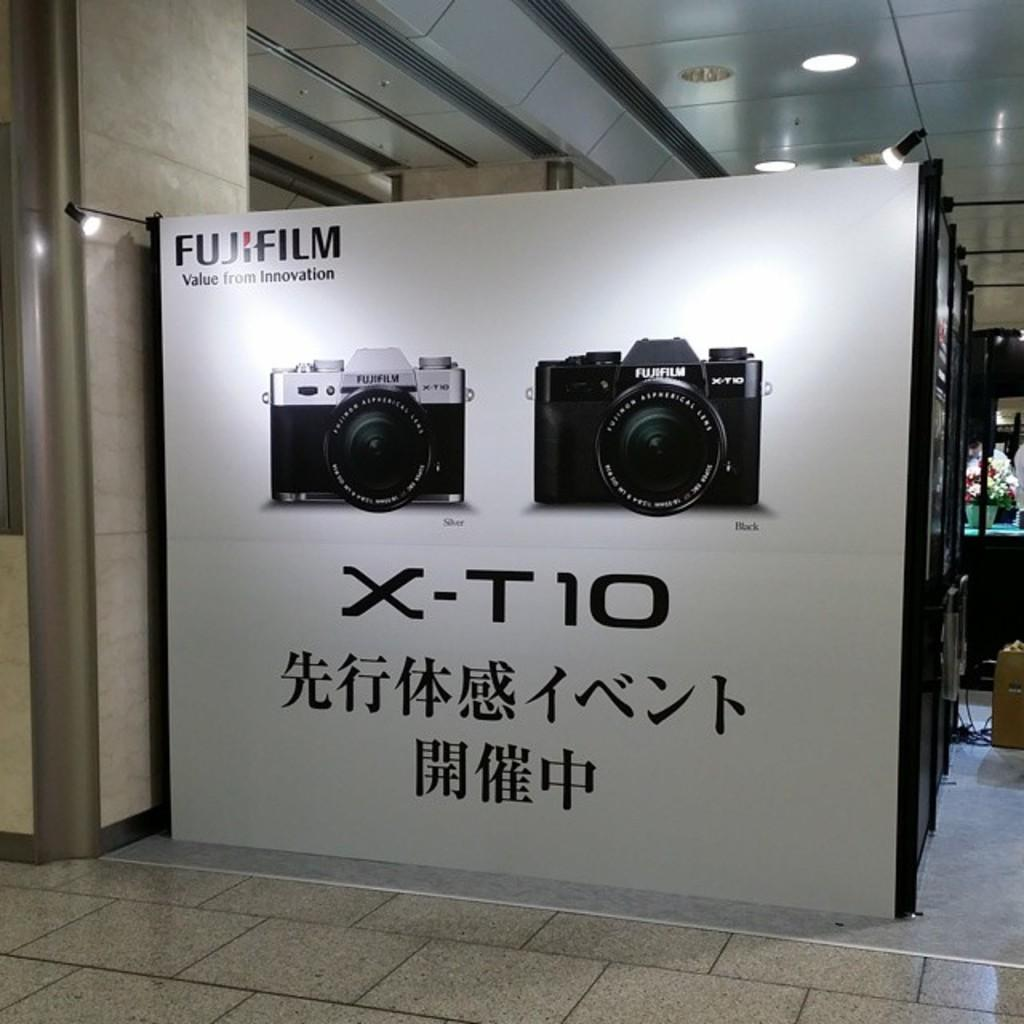Provide a one-sentence caption for the provided image. A wall-sized Fujifilm advertisement shows a new X-T10 camera. 